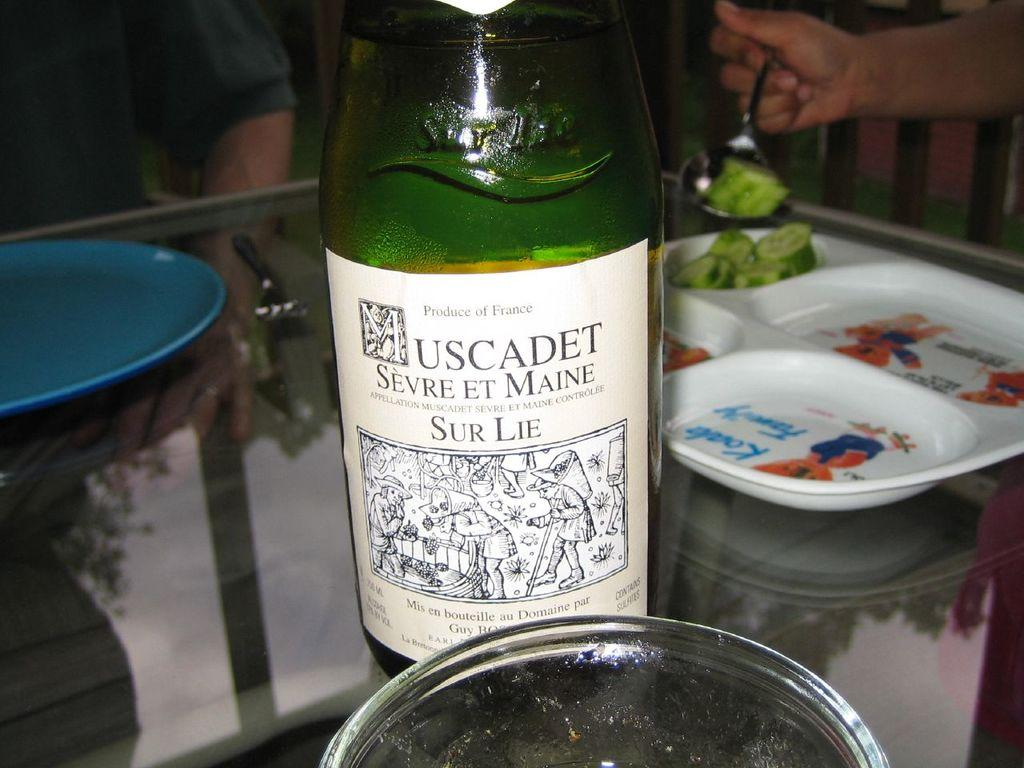What type of bottle is visible in the image? There is a wine bottle in the image. What other objects are present on the table? There is a plate and a fork visible in the image. Where are these objects located? The objects are on a table. Is there anyone near the table? Yes, there is a person sitting in front of the table. What type of canvas is being used by the person sitting in front of the table? There is no canvas present in the image; the person is sitting in front of a table with a wine bottle, plate, and fork. 